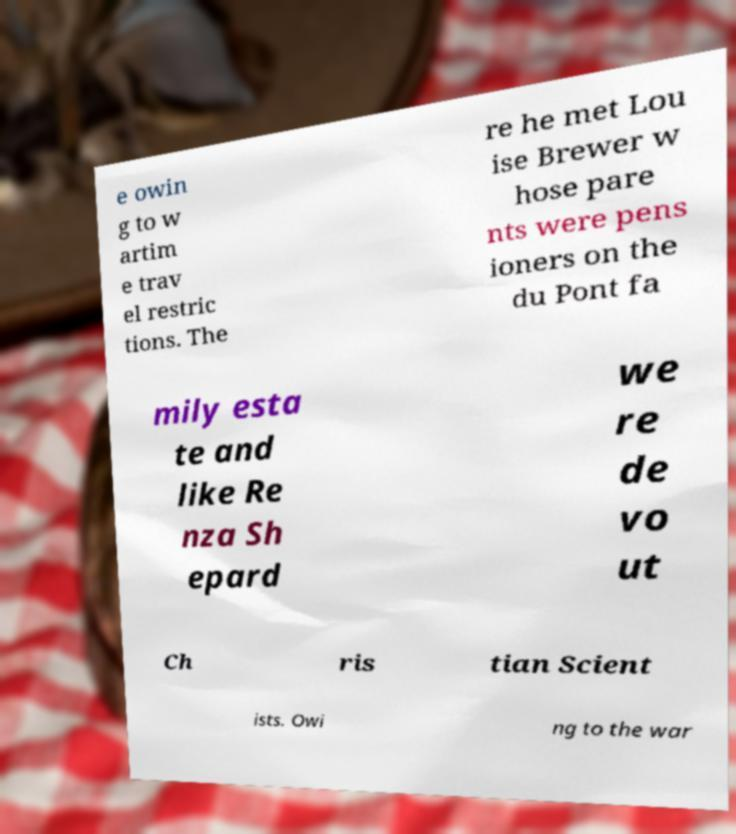Could you assist in decoding the text presented in this image and type it out clearly? e owin g to w artim e trav el restric tions. The re he met Lou ise Brewer w hose pare nts were pens ioners on the du Pont fa mily esta te and like Re nza Sh epard we re de vo ut Ch ris tian Scient ists. Owi ng to the war 